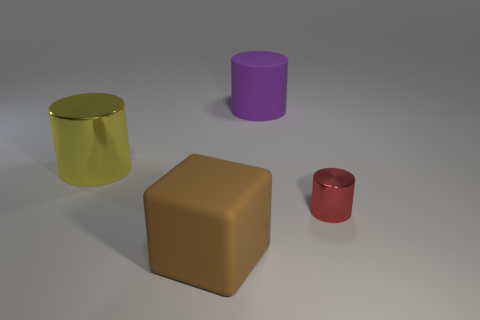Add 4 tiny things. How many objects exist? 8 Subtract all cubes. How many objects are left? 3 Subtract 0 blue spheres. How many objects are left? 4 Subtract all cyan metallic spheres. Subtract all small red things. How many objects are left? 3 Add 2 large matte things. How many large matte things are left? 4 Add 2 brown blocks. How many brown blocks exist? 3 